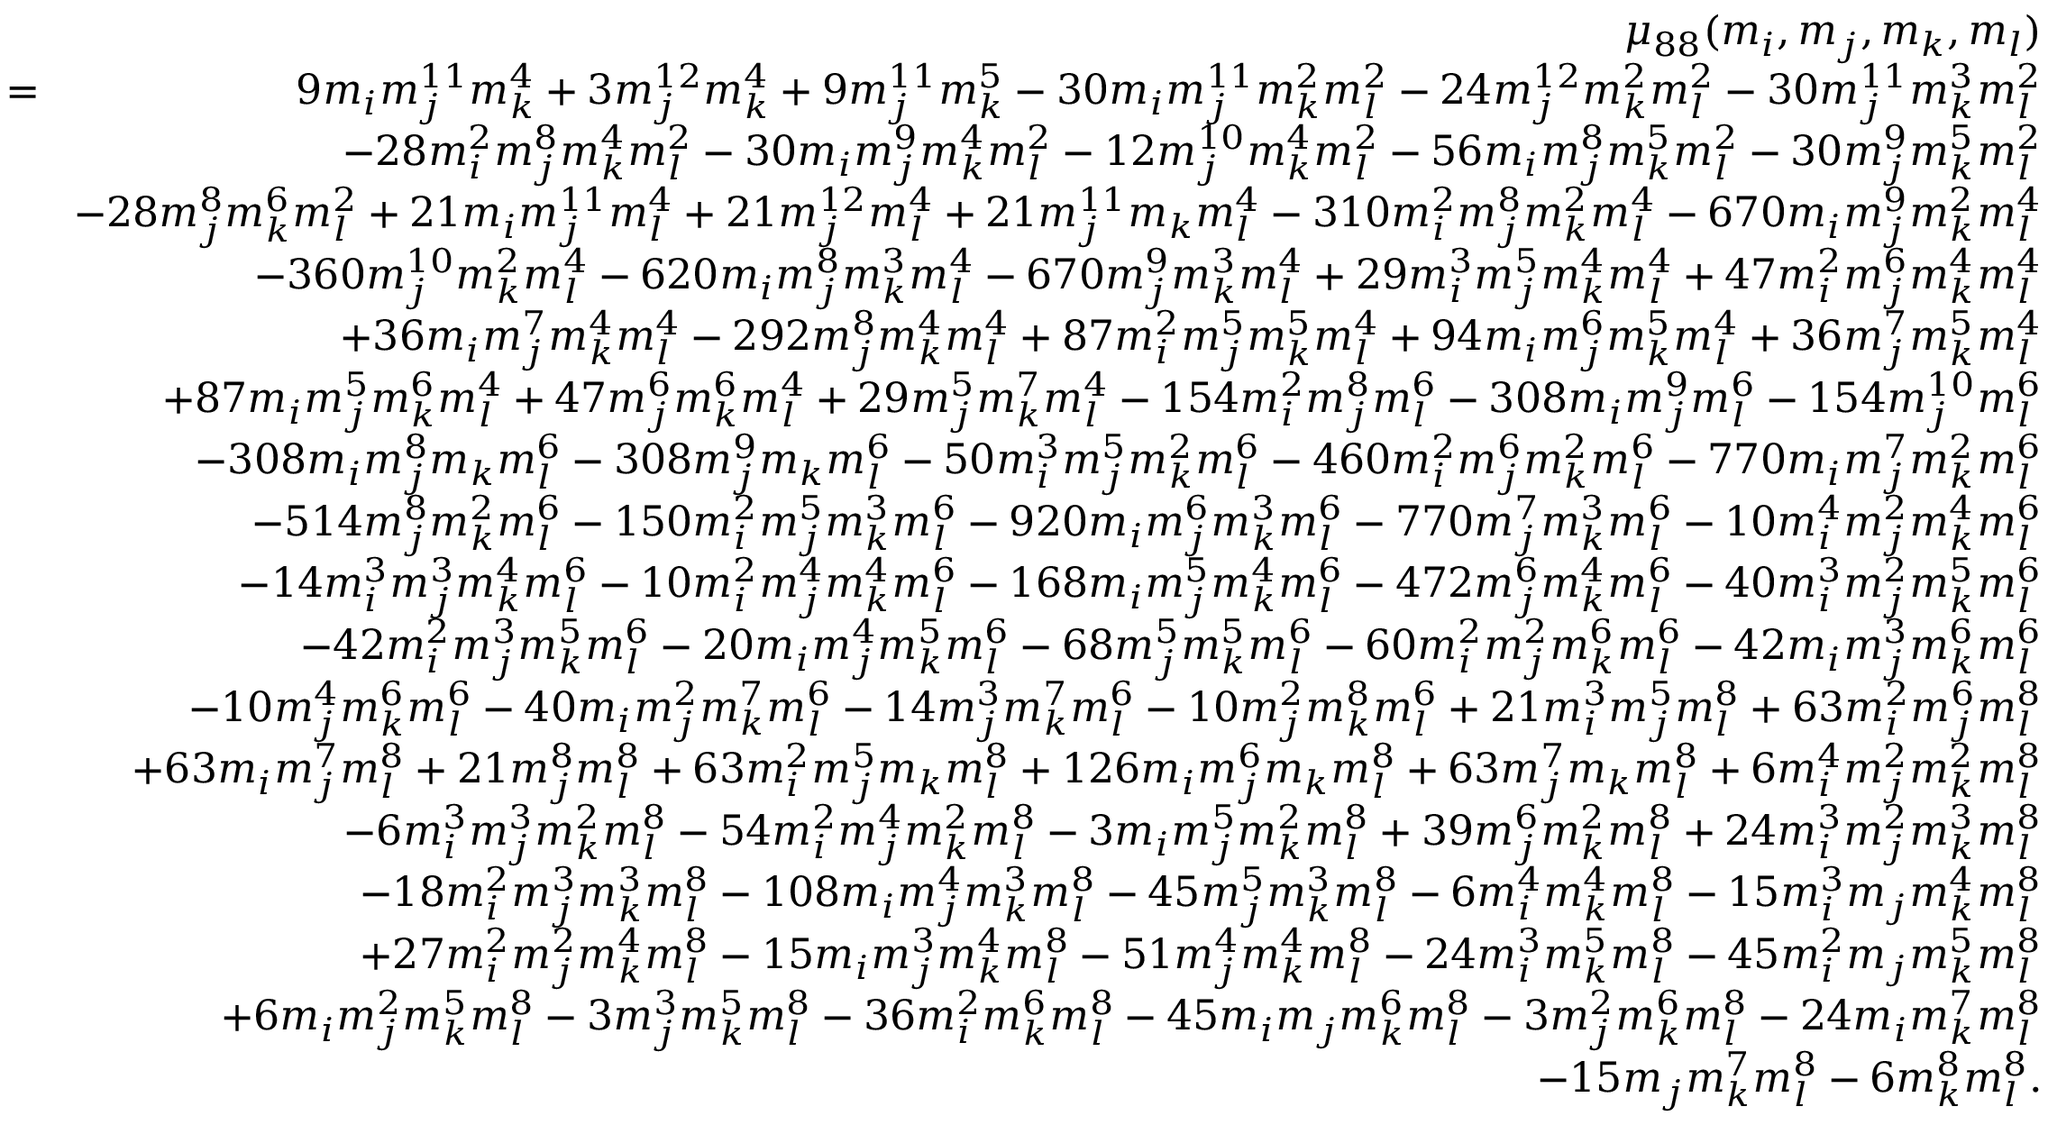Convert formula to latex. <formula><loc_0><loc_0><loc_500><loc_500>\begin{array} { r l r } & { \mu _ { 8 8 } ( m _ { i } , m _ { j } , m _ { k } , m _ { l } ) } \\ & { \, = \, } & { 9 m _ { i } m _ { j } ^ { 1 1 } m _ { k } ^ { 4 } + 3 m _ { j } ^ { 1 2 } m _ { k } ^ { 4 } + 9 m _ { j } ^ { 1 1 } m _ { k } ^ { 5 } - 3 0 m _ { i } m _ { j } ^ { 1 1 } m _ { k } ^ { 2 } m _ { l } ^ { 2 } - 2 4 m _ { j } ^ { 1 2 } m _ { k } ^ { 2 } m _ { l } ^ { 2 } - 3 0 m _ { j } ^ { 1 1 } m _ { k } ^ { 3 } m _ { l } ^ { 2 } } \\ & { - 2 8 m _ { i } ^ { 2 } m _ { j } ^ { 8 } m _ { k } ^ { 4 } m _ { l } ^ { 2 } - 3 0 m _ { i } m _ { j } ^ { 9 } m _ { k } ^ { 4 } m _ { l } ^ { 2 } - 1 2 m _ { j } ^ { 1 0 } m _ { k } ^ { 4 } m _ { l } ^ { 2 } - 5 6 m _ { i } m _ { j } ^ { 8 } m _ { k } ^ { 5 } m _ { l } ^ { 2 } - 3 0 m _ { j } ^ { 9 } m _ { k } ^ { 5 } m _ { l } ^ { 2 } } \\ & { - 2 8 m _ { j } ^ { 8 } m _ { k } ^ { 6 } m _ { l } ^ { 2 } + 2 1 m _ { i } m _ { j } ^ { 1 1 } m _ { l } ^ { 4 } + 2 1 m _ { j } ^ { 1 2 } m _ { l } ^ { 4 } + 2 1 m _ { j } ^ { 1 1 } m _ { k } m _ { l } ^ { 4 } - 3 1 0 m _ { i } ^ { 2 } m _ { j } ^ { 8 } m _ { k } ^ { 2 } m _ { l } ^ { 4 } - 6 7 0 m _ { i } m _ { j } ^ { 9 } m _ { k } ^ { 2 } m _ { l } ^ { 4 } } \\ & { - 3 6 0 m _ { j } ^ { 1 0 } m _ { k } ^ { 2 } m _ { l } ^ { 4 } - 6 2 0 m _ { i } m _ { j } ^ { 8 } m _ { k } ^ { 3 } m _ { l } ^ { 4 } - 6 7 0 m _ { j } ^ { 9 } m _ { k } ^ { 3 } m _ { l } ^ { 4 } + 2 9 m _ { i } ^ { 3 } m _ { j } ^ { 5 } m _ { k } ^ { 4 } m _ { l } ^ { 4 } + 4 7 m _ { i } ^ { 2 } m _ { j } ^ { 6 } m _ { k } ^ { 4 } m _ { l } ^ { 4 } } \\ & { + 3 6 m _ { i } m _ { j } ^ { 7 } m _ { k } ^ { 4 } m _ { l } ^ { 4 } - 2 9 2 m _ { j } ^ { 8 } m _ { k } ^ { 4 } m _ { l } ^ { 4 } + 8 7 m _ { i } ^ { 2 } m _ { j } ^ { 5 } m _ { k } ^ { 5 } m _ { l } ^ { 4 } + 9 4 m _ { i } m _ { j } ^ { 6 } m _ { k } ^ { 5 } m _ { l } ^ { 4 } + 3 6 m _ { j } ^ { 7 } m _ { k } ^ { 5 } m _ { l } ^ { 4 } } \\ & { + 8 7 m _ { i } m _ { j } ^ { 5 } m _ { k } ^ { 6 } m _ { l } ^ { 4 } + 4 7 m _ { j } ^ { 6 } m _ { k } ^ { 6 } m _ { l } ^ { 4 } + 2 9 m _ { j } ^ { 5 } m _ { k } ^ { 7 } m _ { l } ^ { 4 } - 1 5 4 m _ { i } ^ { 2 } m _ { j } ^ { 8 } m _ { l } ^ { 6 } - 3 0 8 m _ { i } m _ { j } ^ { 9 } m _ { l } ^ { 6 } - 1 5 4 m _ { j } ^ { 1 0 } m _ { l } ^ { 6 } } \\ & { - 3 0 8 m _ { i } m _ { j } ^ { 8 } m _ { k } m _ { l } ^ { 6 } - 3 0 8 m _ { j } ^ { 9 } m _ { k } m _ { l } ^ { 6 } - 5 0 m _ { i } ^ { 3 } m _ { j } ^ { 5 } m _ { k } ^ { 2 } m _ { l } ^ { 6 } - 4 6 0 m _ { i } ^ { 2 } m _ { j } ^ { 6 } m _ { k } ^ { 2 } m _ { l } ^ { 6 } - 7 7 0 m _ { i } m _ { j } ^ { 7 } m _ { k } ^ { 2 } m _ { l } ^ { 6 } } \\ & { - 5 1 4 m _ { j } ^ { 8 } m _ { k } ^ { 2 } m _ { l } ^ { 6 } - 1 5 0 m _ { i } ^ { 2 } m _ { j } ^ { 5 } m _ { k } ^ { 3 } m _ { l } ^ { 6 } - 9 2 0 m _ { i } m _ { j } ^ { 6 } m _ { k } ^ { 3 } m _ { l } ^ { 6 } - 7 7 0 m _ { j } ^ { 7 } m _ { k } ^ { 3 } m _ { l } ^ { 6 } - 1 0 m _ { i } ^ { 4 } m _ { j } ^ { 2 } m _ { k } ^ { 4 } m _ { l } ^ { 6 } } \\ & { - 1 4 m _ { i } ^ { 3 } m _ { j } ^ { 3 } m _ { k } ^ { 4 } m _ { l } ^ { 6 } - 1 0 m _ { i } ^ { 2 } m _ { j } ^ { 4 } m _ { k } ^ { 4 } m _ { l } ^ { 6 } - 1 6 8 m _ { i } m _ { j } ^ { 5 } m _ { k } ^ { 4 } m _ { l } ^ { 6 } - 4 7 2 m _ { j } ^ { 6 } m _ { k } ^ { 4 } m _ { l } ^ { 6 } - 4 0 m _ { i } ^ { 3 } m _ { j } ^ { 2 } m _ { k } ^ { 5 } m _ { l } ^ { 6 } } \\ & { - 4 2 m _ { i } ^ { 2 } m _ { j } ^ { 3 } m _ { k } ^ { 5 } m _ { l } ^ { 6 } - 2 0 m _ { i } m _ { j } ^ { 4 } m _ { k } ^ { 5 } m _ { l } ^ { 6 } - 6 8 m _ { j } ^ { 5 } m _ { k } ^ { 5 } m _ { l } ^ { 6 } - 6 0 m _ { i } ^ { 2 } m _ { j } ^ { 2 } m _ { k } ^ { 6 } m _ { l } ^ { 6 } - 4 2 m _ { i } m _ { j } ^ { 3 } m _ { k } ^ { 6 } m _ { l } ^ { 6 } } \\ & { - 1 0 m _ { j } ^ { 4 } m _ { k } ^ { 6 } m _ { l } ^ { 6 } - 4 0 m _ { i } m _ { j } ^ { 2 } m _ { k } ^ { 7 } m _ { l } ^ { 6 } - 1 4 m _ { j } ^ { 3 } m _ { k } ^ { 7 } m _ { l } ^ { 6 } - 1 0 m _ { j } ^ { 2 } m _ { k } ^ { 8 } m _ { l } ^ { 6 } + 2 1 m _ { i } ^ { 3 } m _ { j } ^ { 5 } m _ { l } ^ { 8 } + 6 3 m _ { i } ^ { 2 } m _ { j } ^ { 6 } m _ { l } ^ { 8 } } \\ & { + 6 3 m _ { i } m _ { j } ^ { 7 } m _ { l } ^ { 8 } + 2 1 m _ { j } ^ { 8 } m _ { l } ^ { 8 } + 6 3 m _ { i } ^ { 2 } m _ { j } ^ { 5 } m _ { k } m _ { l } ^ { 8 } + 1 2 6 m _ { i } m _ { j } ^ { 6 } m _ { k } m _ { l } ^ { 8 } + 6 3 m _ { j } ^ { 7 } m _ { k } m _ { l } ^ { 8 } + 6 m _ { i } ^ { 4 } m _ { j } ^ { 2 } m _ { k } ^ { 2 } m _ { l } ^ { 8 } } \\ & { - 6 m _ { i } ^ { 3 } m _ { j } ^ { 3 } m _ { k } ^ { 2 } m _ { l } ^ { 8 } - 5 4 m _ { i } ^ { 2 } m _ { j } ^ { 4 } m _ { k } ^ { 2 } m _ { l } ^ { 8 } - 3 m _ { i } m _ { j } ^ { 5 } m _ { k } ^ { 2 } m _ { l } ^ { 8 } + 3 9 m _ { j } ^ { 6 } m _ { k } ^ { 2 } m _ { l } ^ { 8 } + 2 4 m _ { i } ^ { 3 } m _ { j } ^ { 2 } m _ { k } ^ { 3 } m _ { l } ^ { 8 } } \\ & { - 1 8 m _ { i } ^ { 2 } m _ { j } ^ { 3 } m _ { k } ^ { 3 } m _ { l } ^ { 8 } - 1 0 8 m _ { i } m _ { j } ^ { 4 } m _ { k } ^ { 3 } m _ { l } ^ { 8 } - 4 5 m _ { j } ^ { 5 } m _ { k } ^ { 3 } m _ { l } ^ { 8 } - 6 m _ { i } ^ { 4 } m _ { k } ^ { 4 } m _ { l } ^ { 8 } - 1 5 m _ { i } ^ { 3 } m _ { j } m _ { k } ^ { 4 } m _ { l } ^ { 8 } } \\ & { + 2 7 m _ { i } ^ { 2 } m _ { j } ^ { 2 } m _ { k } ^ { 4 } m _ { l } ^ { 8 } - 1 5 m _ { i } m _ { j } ^ { 3 } m _ { k } ^ { 4 } m _ { l } ^ { 8 } - 5 1 m _ { j } ^ { 4 } m _ { k } ^ { 4 } m _ { l } ^ { 8 } - 2 4 m _ { i } ^ { 3 } m _ { k } ^ { 5 } m _ { l } ^ { 8 } - 4 5 m _ { i } ^ { 2 } m _ { j } m _ { k } ^ { 5 } m _ { l } ^ { 8 } } \\ & { + 6 m _ { i } m _ { j } ^ { 2 } m _ { k } ^ { 5 } m _ { l } ^ { 8 } - 3 m _ { j } ^ { 3 } m _ { k } ^ { 5 } m _ { l } ^ { 8 } - 3 6 m _ { i } ^ { 2 } m _ { k } ^ { 6 } m _ { l } ^ { 8 } - 4 5 m _ { i } m _ { j } m _ { k } ^ { 6 } m _ { l } ^ { 8 } - 3 m _ { j } ^ { 2 } m _ { k } ^ { 6 } m _ { l } ^ { 8 } - 2 4 m _ { i } m _ { k } ^ { 7 } m _ { l } ^ { 8 } } \\ & { - 1 5 m _ { j } m _ { k } ^ { 7 } m _ { l } ^ { 8 } - 6 m _ { k } ^ { 8 } m _ { l } ^ { 8 } . } \end{array}</formula> 